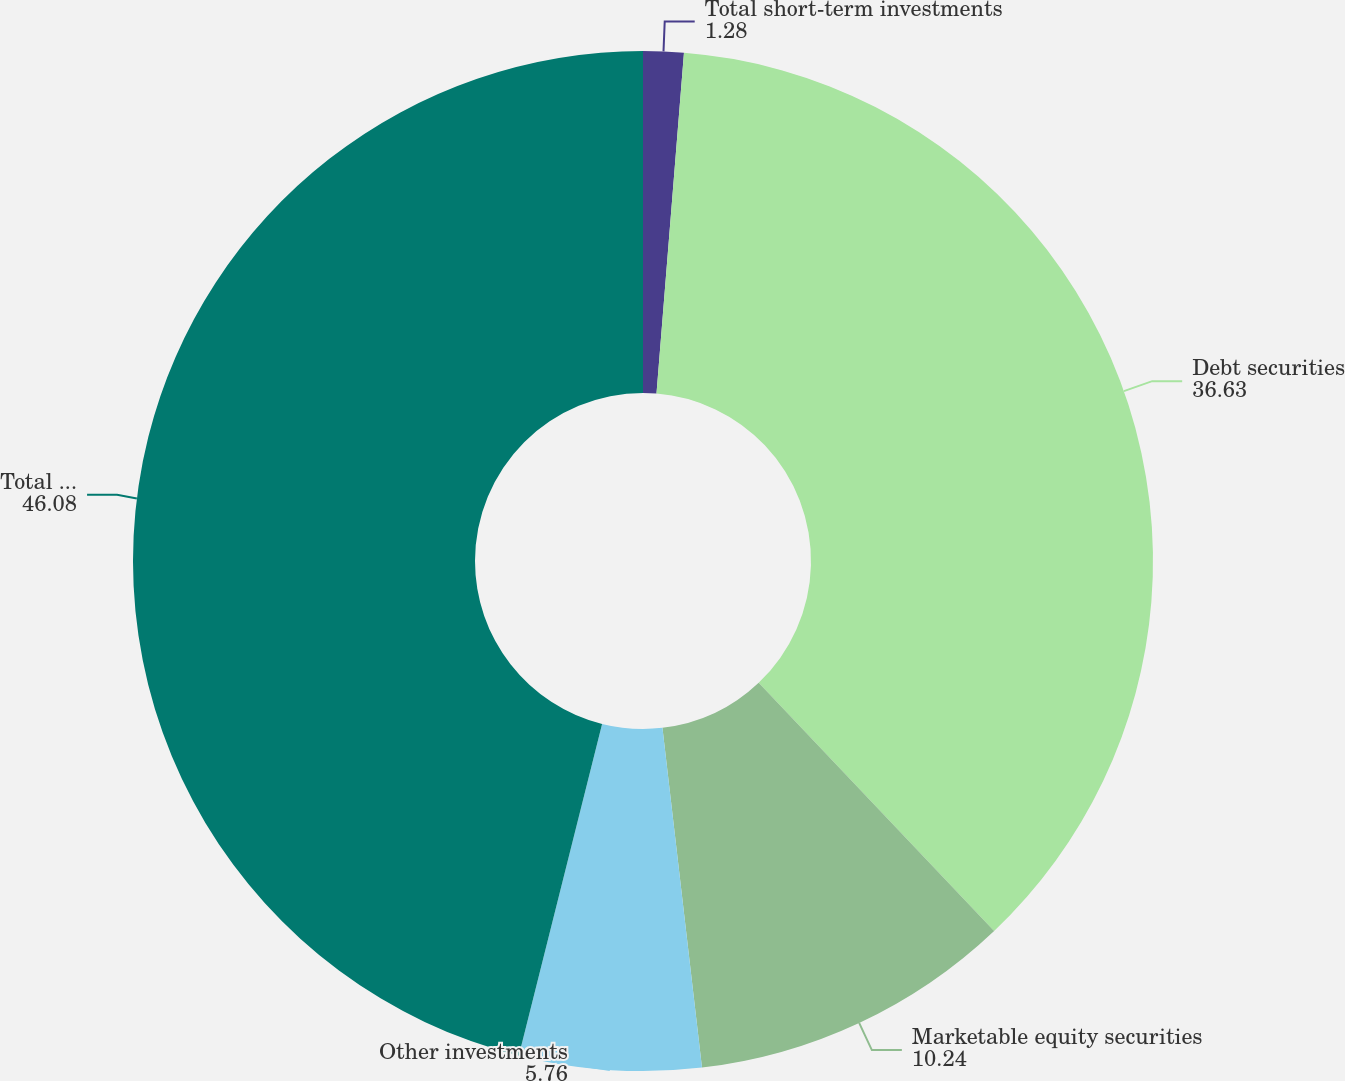<chart> <loc_0><loc_0><loc_500><loc_500><pie_chart><fcel>Total short-term investments<fcel>Debt securities<fcel>Marketable equity securities<fcel>Other investments<fcel>Total equity and other<nl><fcel>1.28%<fcel>36.63%<fcel>10.24%<fcel>5.76%<fcel>46.08%<nl></chart> 